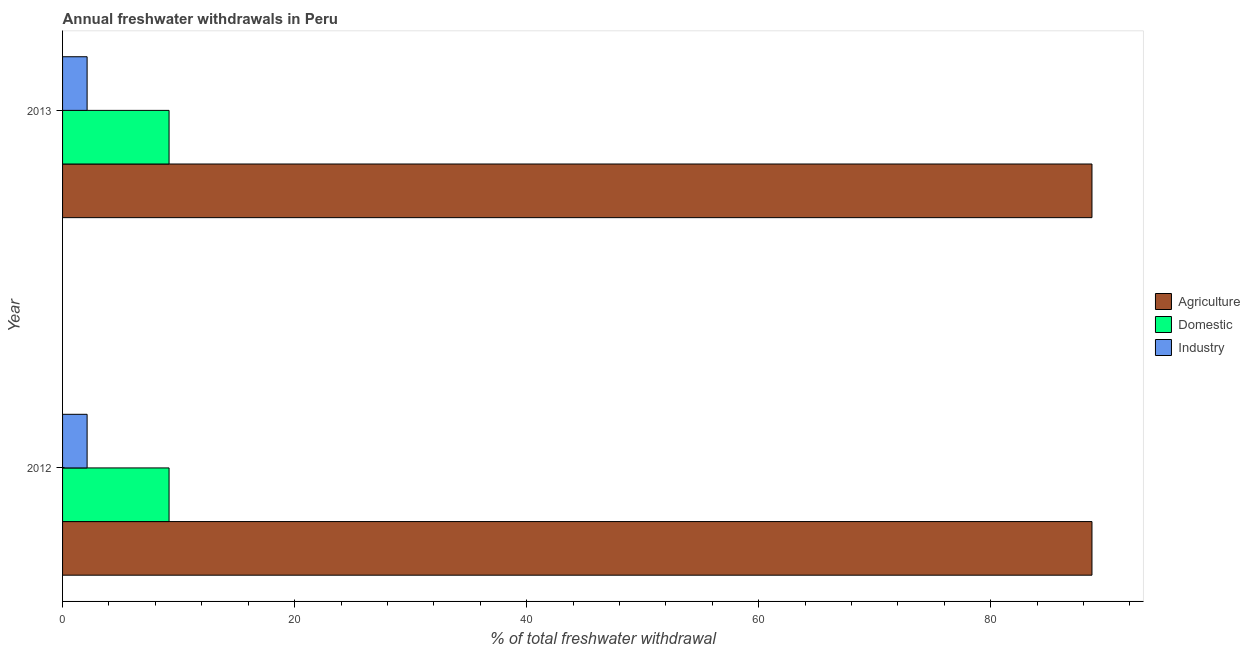How many different coloured bars are there?
Keep it short and to the point. 3. How many bars are there on the 1st tick from the bottom?
Offer a terse response. 3. In how many cases, is the number of bars for a given year not equal to the number of legend labels?
Provide a succinct answer. 0. What is the percentage of freshwater withdrawal for agriculture in 2012?
Provide a succinct answer. 88.73. Across all years, what is the maximum percentage of freshwater withdrawal for domestic purposes?
Give a very brief answer. 9.18. Across all years, what is the minimum percentage of freshwater withdrawal for domestic purposes?
Provide a short and direct response. 9.18. What is the total percentage of freshwater withdrawal for industry in the graph?
Your answer should be compact. 4.23. What is the difference between the percentage of freshwater withdrawal for agriculture in 2012 and that in 2013?
Your answer should be very brief. 0. What is the difference between the percentage of freshwater withdrawal for agriculture in 2012 and the percentage of freshwater withdrawal for industry in 2013?
Keep it short and to the point. 86.61. What is the average percentage of freshwater withdrawal for domestic purposes per year?
Provide a short and direct response. 9.18. In the year 2013, what is the difference between the percentage of freshwater withdrawal for agriculture and percentage of freshwater withdrawal for domestic purposes?
Offer a terse response. 79.55. In how many years, is the percentage of freshwater withdrawal for agriculture greater than 8 %?
Provide a short and direct response. 2. What is the ratio of the percentage of freshwater withdrawal for domestic purposes in 2012 to that in 2013?
Ensure brevity in your answer.  1. Is the percentage of freshwater withdrawal for agriculture in 2012 less than that in 2013?
Offer a very short reply. No. What does the 1st bar from the top in 2012 represents?
Offer a terse response. Industry. What does the 1st bar from the bottom in 2012 represents?
Ensure brevity in your answer.  Agriculture. Is it the case that in every year, the sum of the percentage of freshwater withdrawal for agriculture and percentage of freshwater withdrawal for domestic purposes is greater than the percentage of freshwater withdrawal for industry?
Your response must be concise. Yes. Are the values on the major ticks of X-axis written in scientific E-notation?
Your answer should be compact. No. Does the graph contain any zero values?
Provide a succinct answer. No. Does the graph contain grids?
Your response must be concise. No. Where does the legend appear in the graph?
Keep it short and to the point. Center right. How many legend labels are there?
Offer a terse response. 3. What is the title of the graph?
Provide a succinct answer. Annual freshwater withdrawals in Peru. What is the label or title of the X-axis?
Your answer should be very brief. % of total freshwater withdrawal. What is the % of total freshwater withdrawal of Agriculture in 2012?
Keep it short and to the point. 88.73. What is the % of total freshwater withdrawal of Domestic in 2012?
Ensure brevity in your answer.  9.18. What is the % of total freshwater withdrawal of Industry in 2012?
Your response must be concise. 2.12. What is the % of total freshwater withdrawal in Agriculture in 2013?
Provide a succinct answer. 88.73. What is the % of total freshwater withdrawal in Domestic in 2013?
Your response must be concise. 9.18. What is the % of total freshwater withdrawal of Industry in 2013?
Provide a succinct answer. 2.12. Across all years, what is the maximum % of total freshwater withdrawal of Agriculture?
Your answer should be compact. 88.73. Across all years, what is the maximum % of total freshwater withdrawal in Domestic?
Offer a terse response. 9.18. Across all years, what is the maximum % of total freshwater withdrawal in Industry?
Your answer should be compact. 2.12. Across all years, what is the minimum % of total freshwater withdrawal of Agriculture?
Your answer should be very brief. 88.73. Across all years, what is the minimum % of total freshwater withdrawal in Domestic?
Offer a very short reply. 9.18. Across all years, what is the minimum % of total freshwater withdrawal of Industry?
Provide a succinct answer. 2.12. What is the total % of total freshwater withdrawal in Agriculture in the graph?
Keep it short and to the point. 177.46. What is the total % of total freshwater withdrawal in Domestic in the graph?
Give a very brief answer. 18.36. What is the total % of total freshwater withdrawal of Industry in the graph?
Provide a short and direct response. 4.23. What is the difference between the % of total freshwater withdrawal of Industry in 2012 and that in 2013?
Offer a very short reply. 0. What is the difference between the % of total freshwater withdrawal in Agriculture in 2012 and the % of total freshwater withdrawal in Domestic in 2013?
Your answer should be very brief. 79.55. What is the difference between the % of total freshwater withdrawal in Agriculture in 2012 and the % of total freshwater withdrawal in Industry in 2013?
Offer a terse response. 86.61. What is the difference between the % of total freshwater withdrawal in Domestic in 2012 and the % of total freshwater withdrawal in Industry in 2013?
Make the answer very short. 7.06. What is the average % of total freshwater withdrawal of Agriculture per year?
Ensure brevity in your answer.  88.73. What is the average % of total freshwater withdrawal of Domestic per year?
Provide a succinct answer. 9.18. What is the average % of total freshwater withdrawal of Industry per year?
Your answer should be compact. 2.12. In the year 2012, what is the difference between the % of total freshwater withdrawal of Agriculture and % of total freshwater withdrawal of Domestic?
Your response must be concise. 79.55. In the year 2012, what is the difference between the % of total freshwater withdrawal of Agriculture and % of total freshwater withdrawal of Industry?
Make the answer very short. 86.61. In the year 2012, what is the difference between the % of total freshwater withdrawal in Domestic and % of total freshwater withdrawal in Industry?
Give a very brief answer. 7.06. In the year 2013, what is the difference between the % of total freshwater withdrawal in Agriculture and % of total freshwater withdrawal in Domestic?
Give a very brief answer. 79.55. In the year 2013, what is the difference between the % of total freshwater withdrawal of Agriculture and % of total freshwater withdrawal of Industry?
Your response must be concise. 86.61. In the year 2013, what is the difference between the % of total freshwater withdrawal of Domestic and % of total freshwater withdrawal of Industry?
Provide a succinct answer. 7.06. What is the ratio of the % of total freshwater withdrawal of Domestic in 2012 to that in 2013?
Your response must be concise. 1. What is the difference between the highest and the second highest % of total freshwater withdrawal of Agriculture?
Offer a terse response. 0. What is the difference between the highest and the second highest % of total freshwater withdrawal in Domestic?
Offer a very short reply. 0. What is the difference between the highest and the lowest % of total freshwater withdrawal in Agriculture?
Your answer should be compact. 0. What is the difference between the highest and the lowest % of total freshwater withdrawal of Domestic?
Provide a succinct answer. 0. What is the difference between the highest and the lowest % of total freshwater withdrawal in Industry?
Make the answer very short. 0. 